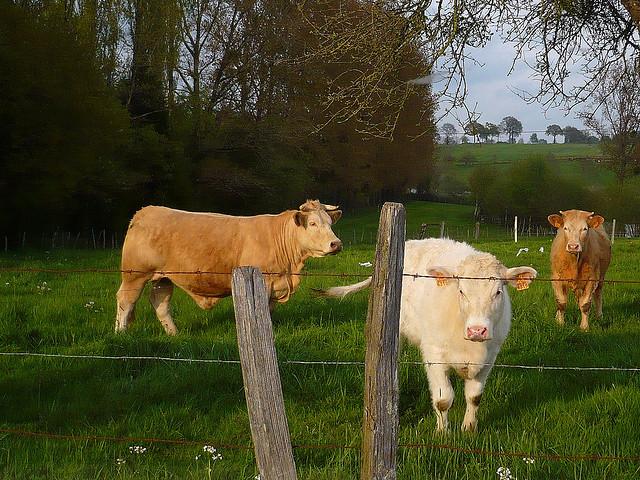Is there a difference between the white cow and the brown cows?
Answer briefly. Yes. How many cows are there?
Answer briefly. 3. Is the white cow feeding?
Answer briefly. No. What type of animals are here?
Answer briefly. Cows. What are the cattle for?
Short answer required. Milk. Will the cows get hurt if they rub up against the fence?
Be succinct. Yes. What animal are this?
Quick response, please. Cows. What animals are in the pen behind the horse?
Be succinct. Cows. How many cows are standing in this field?
Short answer required. 3. 